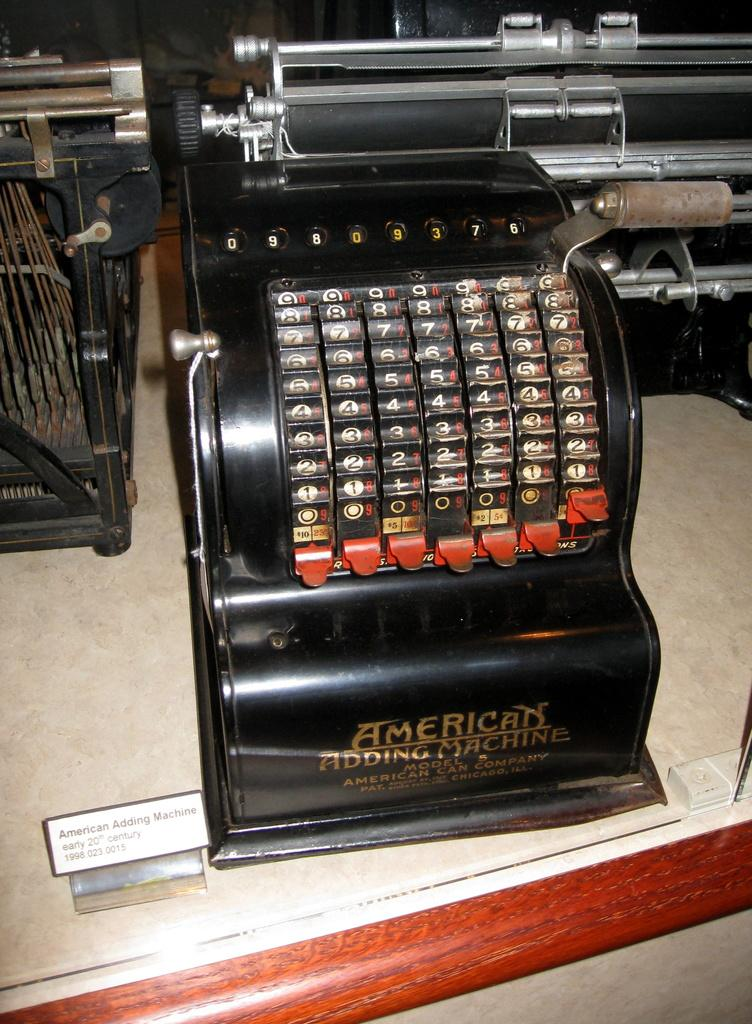<image>
Share a concise interpretation of the image provided. An adding machine by the American Can Company dates from the early 1900s. 